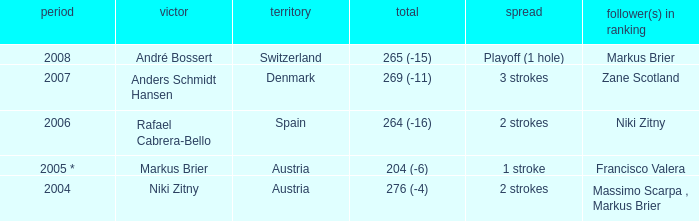In what year was the score 204 (-6)? 2005 *. 